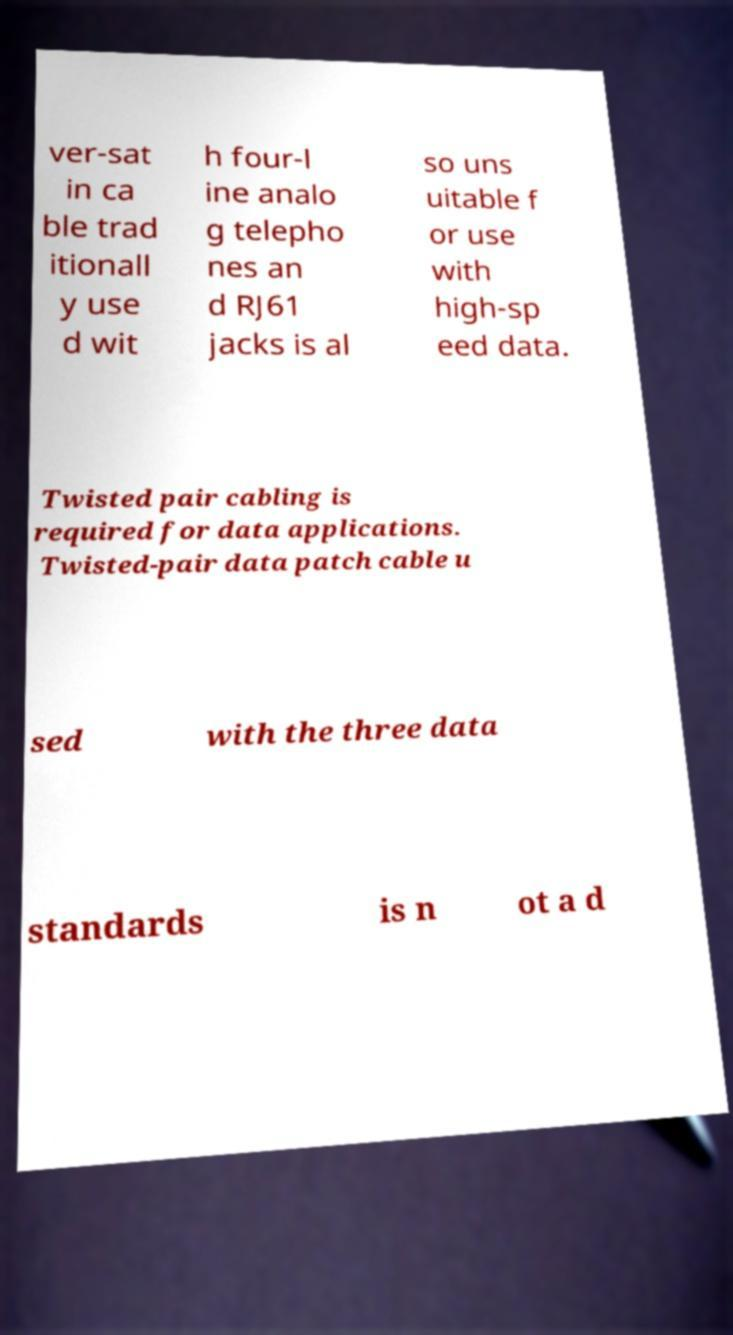For documentation purposes, I need the text within this image transcribed. Could you provide that? ver-sat in ca ble trad itionall y use d wit h four-l ine analo g telepho nes an d RJ61 jacks is al so uns uitable f or use with high-sp eed data. Twisted pair cabling is required for data applications. Twisted-pair data patch cable u sed with the three data standards is n ot a d 